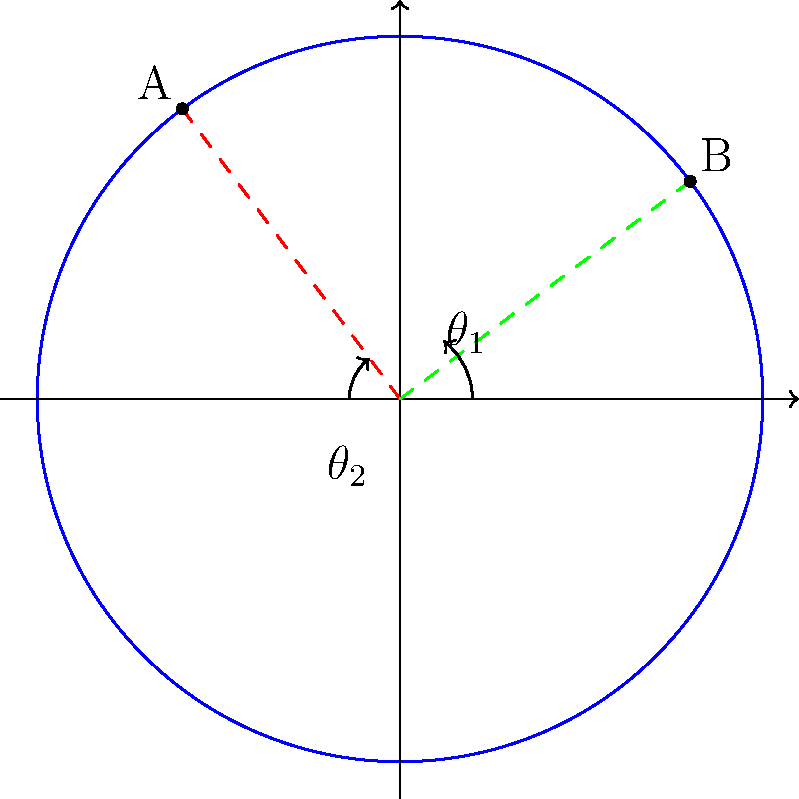In the circular harbor of Aransas County, two popular tourist boat routes are represented by vectors $\vec{OA}$ and $\vec{OB}$ in polar coordinates. If $\vec{OA}$ has a magnitude of 5 units and makes an angle of $\frac{2\pi}{3}$ radians with the positive x-axis, while $\vec{OB}$ has a magnitude of 5 units and makes an angle of $\frac{\pi}{4}$ radians with the positive x-axis, what is the shortest angular distance (in radians) between these two routes? To find the shortest angular distance between the two boat routes, we need to follow these steps:

1) First, we need to identify the angles of both vectors:
   $\theta_1 = \frac{2\pi}{3}$ for $\vec{OA}$
   $\theta_2 = \frac{\pi}{4}$ for $\vec{OB}$

2) The angular distance between these vectors is the absolute difference between their angles:
   $|\theta_1 - \theta_2| = |\frac{2\pi}{3} - \frac{\pi}{4}|$

3) Simplify the fraction:
   $|\frac{8\pi}{12} - \frac{3\pi}{12}| = |\frac{5\pi}{12}|$

4) Since we're dealing with the absolute value, the result is already positive, so we can remove the absolute value signs:
   $\frac{5\pi}{12}$

5) This is the shortest angular distance in the counterclockwise direction. However, we need to check if going clockwise would give a shorter distance:
   $2\pi - \frac{5\pi}{12} = \frac{24\pi}{12} - \frac{5\pi}{12} = \frac{19\pi}{12}$

6) The shorter of these two is $\frac{5\pi}{12}$, which is approximately 1.309 radians.

Therefore, the shortest angular distance between the two boat routes is $\frac{5\pi}{12}$ radians.
Answer: $\frac{5\pi}{12}$ radians 